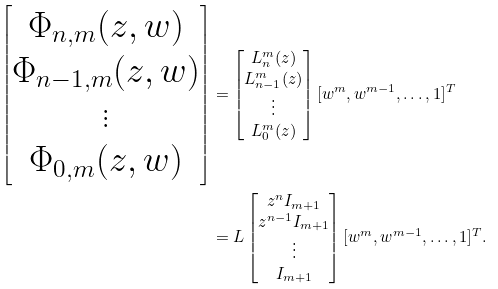<formula> <loc_0><loc_0><loc_500><loc_500>\left [ \begin{matrix} \Phi _ { n , m } ( z , w ) \\ \Phi _ { n - 1 , m } ( z , w ) \\ \vdots \\ \Phi _ { 0 , m } ( z , w ) \end{matrix} \right ] & = \left [ \begin{matrix} L ^ { m } _ { n } ( z ) \\ L ^ { m } _ { n - 1 } ( z ) \\ \vdots \\ L ^ { m } _ { 0 } ( z ) \end{matrix} \right ] [ w ^ { m } , w ^ { m - 1 } , \dots , 1 ] ^ { T } \\ & = L \left [ \begin{matrix} z ^ { n } I _ { m + 1 } \\ z ^ { n - 1 } I _ { m + 1 } \\ \vdots \\ I _ { m + 1 } \end{matrix} \right ] [ w ^ { m } , w ^ { m - 1 } , \dots , 1 ] ^ { T } .</formula> 